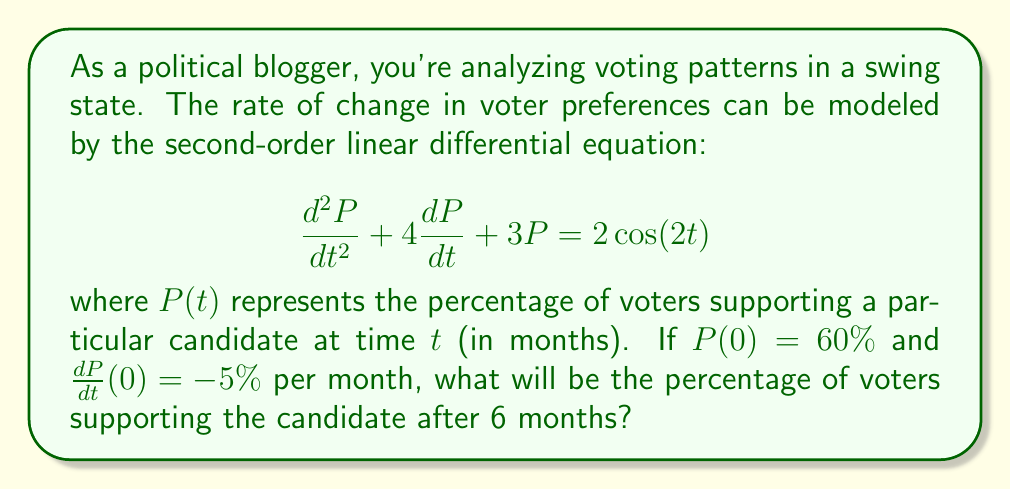Help me with this question. To solve this problem, we need to find the general solution to the differential equation and then apply the initial conditions.

1) The homogeneous solution:
The characteristic equation is $r^2 + 4r + 3 = 0$
Solving this: $r = -1$ or $r = -3$
So, the homogeneous solution is: $P_h(t) = c_1e^{-t} + c_2e^{-3t}$

2) The particular solution:
We guess a solution of the form $P_p(t) = A\cos(2t) + B\sin(2t)$
Substituting this into the original equation and solving for A and B:
$A = \frac{2(3-4)}{(3-4)^2+16} = -\frac{1}{5}$, $B = \frac{2(8)}{(3-4)^2+16} = \frac{8}{25}$

So, $P_p(t) = -\frac{1}{5}\cos(2t) + \frac{8}{25}\sin(2t)$

3) The general solution:
$P(t) = P_h(t) + P_p(t) = c_1e^{-t} + c_2e^{-3t} - \frac{1}{5}\cos(2t) + \frac{8}{25}\sin(2t)$

4) Applying initial conditions:
$P(0) = 60\%$ gives: $c_1 + c_2 - \frac{1}{5} = 0.6$

$\frac{dP}{dt}(0) = -5\%$ gives: $-c_1 - 3c_2 + \frac{16}{25} = -0.05$

Solving these simultaneously:
$c_1 = \frac{39}{40}$, $c_2 = -\frac{7}{200}$

5) The final solution:
$P(t) = \frac{39}{40}e^{-t} - \frac{7}{200}e^{-3t} - \frac{1}{5}\cos(2t) + \frac{8}{25}\sin(2t)$

6) Evaluating at t = 6:
$P(6) = \frac{39}{40}e^{-6} - \frac{7}{200}e^{-18} - \frac{1}{5}\cos(12) + \frac{8}{25}\sin(12)$
Answer: $P(6) \approx 51.76\%$

The percentage of voters supporting the candidate after 6 months will be approximately 51.76%. 